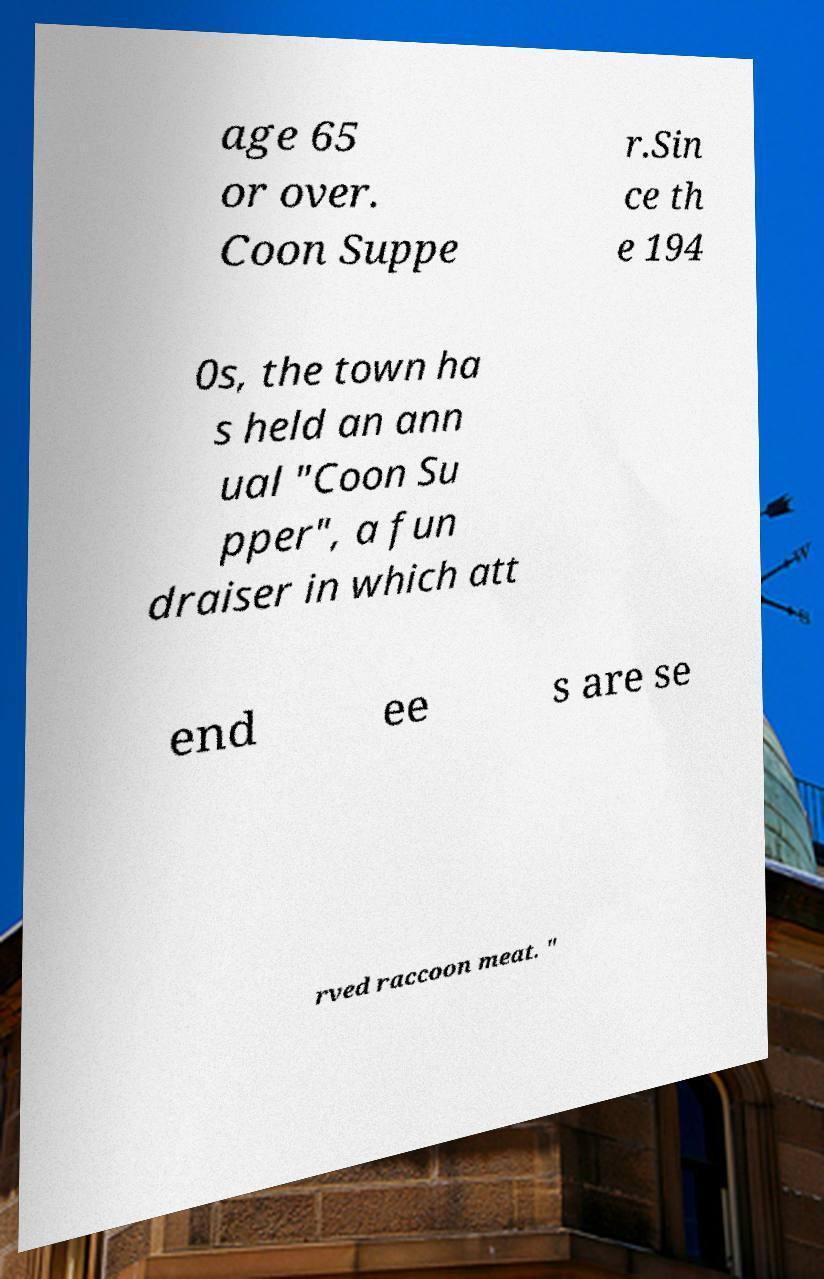Can you accurately transcribe the text from the provided image for me? age 65 or over. Coon Suppe r.Sin ce th e 194 0s, the town ha s held an ann ual "Coon Su pper", a fun draiser in which att end ee s are se rved raccoon meat. " 